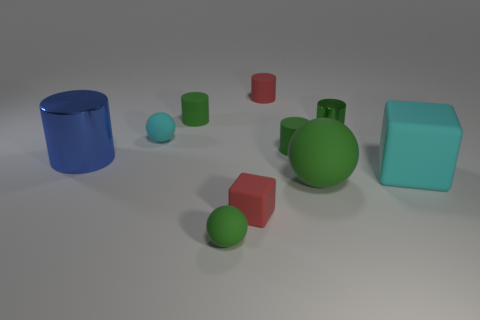Can you tell which object is the largest? The largest object in the image is the green bottle with a cylindrical body and conical neck, located towards the center. It is both taller and appears to have a greater volume than the other shapes present. 